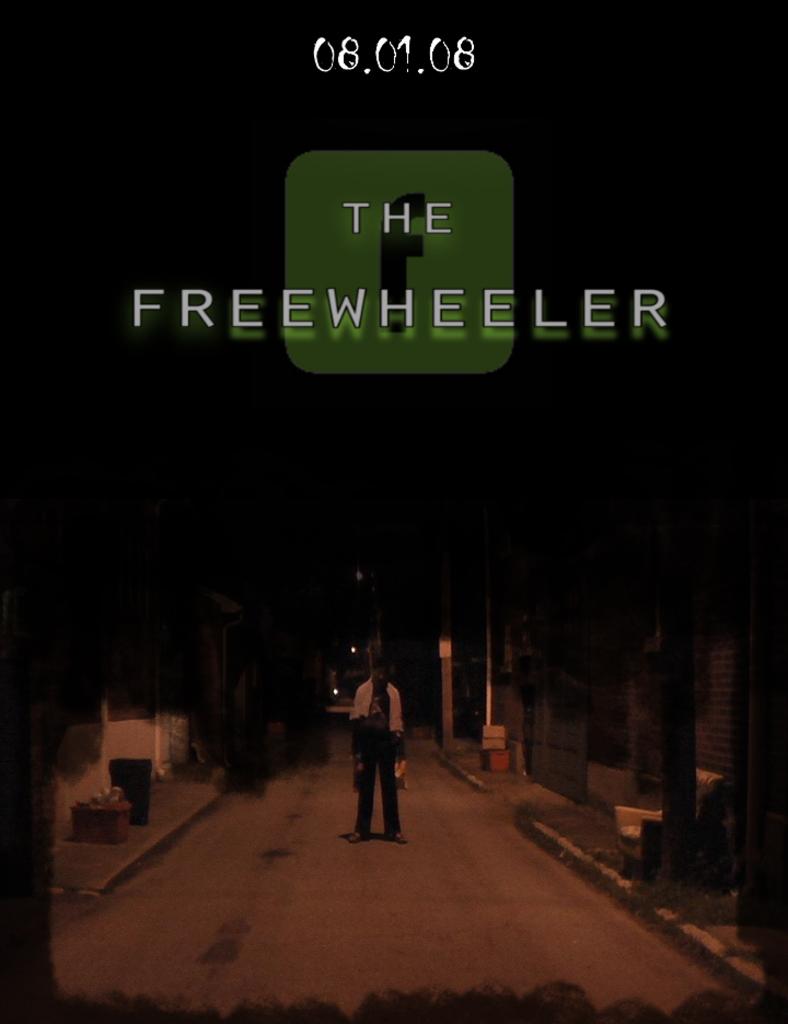What is the title?
Offer a very short reply. The freewheeler. What are the numbers at the top of the page?
Offer a terse response. 08.01.08. 